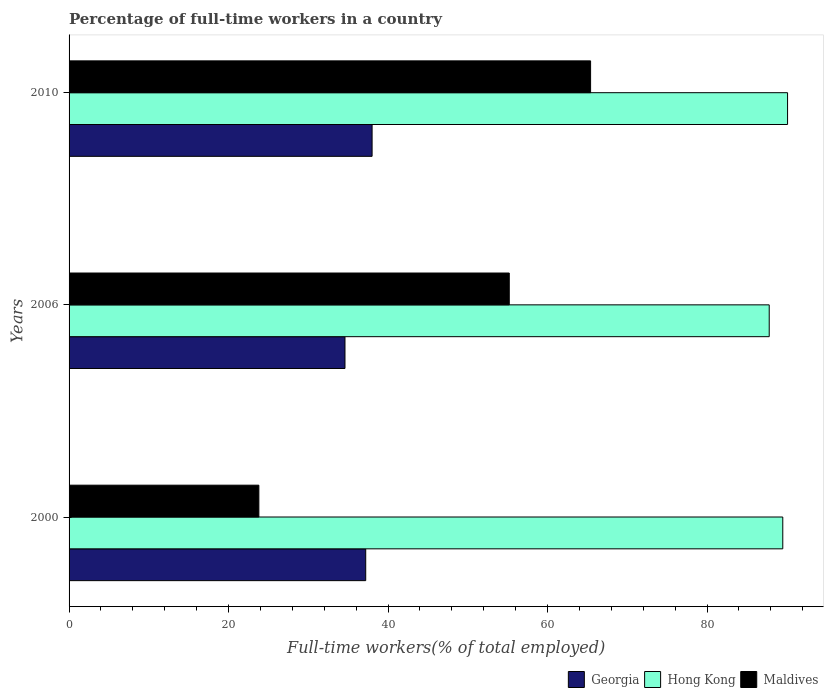How many groups of bars are there?
Provide a succinct answer. 3. Are the number of bars per tick equal to the number of legend labels?
Offer a terse response. Yes. Are the number of bars on each tick of the Y-axis equal?
Your answer should be very brief. Yes. What is the label of the 3rd group of bars from the top?
Make the answer very short. 2000. What is the percentage of full-time workers in Hong Kong in 2006?
Offer a terse response. 87.8. Across all years, what is the minimum percentage of full-time workers in Hong Kong?
Your response must be concise. 87.8. What is the total percentage of full-time workers in Hong Kong in the graph?
Provide a succinct answer. 267.4. What is the difference between the percentage of full-time workers in Georgia in 2000 and that in 2006?
Keep it short and to the point. 2.6. What is the difference between the percentage of full-time workers in Georgia in 2006 and the percentage of full-time workers in Hong Kong in 2000?
Offer a terse response. -54.9. What is the average percentage of full-time workers in Maldives per year?
Give a very brief answer. 48.13. In the year 2010, what is the difference between the percentage of full-time workers in Georgia and percentage of full-time workers in Maldives?
Your response must be concise. -27.4. In how many years, is the percentage of full-time workers in Georgia greater than 8 %?
Make the answer very short. 3. What is the ratio of the percentage of full-time workers in Hong Kong in 2000 to that in 2006?
Your answer should be compact. 1.02. Is the difference between the percentage of full-time workers in Georgia in 2006 and 2010 greater than the difference between the percentage of full-time workers in Maldives in 2006 and 2010?
Offer a terse response. Yes. What is the difference between the highest and the second highest percentage of full-time workers in Maldives?
Provide a succinct answer. 10.2. What is the difference between the highest and the lowest percentage of full-time workers in Hong Kong?
Keep it short and to the point. 2.3. In how many years, is the percentage of full-time workers in Hong Kong greater than the average percentage of full-time workers in Hong Kong taken over all years?
Provide a succinct answer. 2. Is the sum of the percentage of full-time workers in Maldives in 2006 and 2010 greater than the maximum percentage of full-time workers in Georgia across all years?
Make the answer very short. Yes. What does the 3rd bar from the top in 2006 represents?
Ensure brevity in your answer.  Georgia. What does the 1st bar from the bottom in 2006 represents?
Your answer should be compact. Georgia. How many bars are there?
Give a very brief answer. 9. Are all the bars in the graph horizontal?
Your answer should be compact. Yes. How many legend labels are there?
Give a very brief answer. 3. What is the title of the graph?
Your answer should be compact. Percentage of full-time workers in a country. Does "Luxembourg" appear as one of the legend labels in the graph?
Your response must be concise. No. What is the label or title of the X-axis?
Your answer should be compact. Full-time workers(% of total employed). What is the Full-time workers(% of total employed) of Georgia in 2000?
Offer a very short reply. 37.2. What is the Full-time workers(% of total employed) in Hong Kong in 2000?
Your answer should be compact. 89.5. What is the Full-time workers(% of total employed) of Maldives in 2000?
Offer a terse response. 23.8. What is the Full-time workers(% of total employed) in Georgia in 2006?
Offer a very short reply. 34.6. What is the Full-time workers(% of total employed) in Hong Kong in 2006?
Your answer should be very brief. 87.8. What is the Full-time workers(% of total employed) of Maldives in 2006?
Keep it short and to the point. 55.2. What is the Full-time workers(% of total employed) of Hong Kong in 2010?
Provide a succinct answer. 90.1. What is the Full-time workers(% of total employed) of Maldives in 2010?
Offer a very short reply. 65.4. Across all years, what is the maximum Full-time workers(% of total employed) in Hong Kong?
Your answer should be very brief. 90.1. Across all years, what is the maximum Full-time workers(% of total employed) in Maldives?
Keep it short and to the point. 65.4. Across all years, what is the minimum Full-time workers(% of total employed) in Georgia?
Provide a succinct answer. 34.6. Across all years, what is the minimum Full-time workers(% of total employed) of Hong Kong?
Provide a short and direct response. 87.8. Across all years, what is the minimum Full-time workers(% of total employed) in Maldives?
Give a very brief answer. 23.8. What is the total Full-time workers(% of total employed) in Georgia in the graph?
Your response must be concise. 109.8. What is the total Full-time workers(% of total employed) of Hong Kong in the graph?
Provide a short and direct response. 267.4. What is the total Full-time workers(% of total employed) of Maldives in the graph?
Offer a very short reply. 144.4. What is the difference between the Full-time workers(% of total employed) of Hong Kong in 2000 and that in 2006?
Offer a very short reply. 1.7. What is the difference between the Full-time workers(% of total employed) in Maldives in 2000 and that in 2006?
Your response must be concise. -31.4. What is the difference between the Full-time workers(% of total employed) of Georgia in 2000 and that in 2010?
Make the answer very short. -0.8. What is the difference between the Full-time workers(% of total employed) of Hong Kong in 2000 and that in 2010?
Keep it short and to the point. -0.6. What is the difference between the Full-time workers(% of total employed) of Maldives in 2000 and that in 2010?
Your answer should be compact. -41.6. What is the difference between the Full-time workers(% of total employed) of Georgia in 2000 and the Full-time workers(% of total employed) of Hong Kong in 2006?
Keep it short and to the point. -50.6. What is the difference between the Full-time workers(% of total employed) of Georgia in 2000 and the Full-time workers(% of total employed) of Maldives in 2006?
Your response must be concise. -18. What is the difference between the Full-time workers(% of total employed) of Hong Kong in 2000 and the Full-time workers(% of total employed) of Maldives in 2006?
Your response must be concise. 34.3. What is the difference between the Full-time workers(% of total employed) in Georgia in 2000 and the Full-time workers(% of total employed) in Hong Kong in 2010?
Offer a terse response. -52.9. What is the difference between the Full-time workers(% of total employed) of Georgia in 2000 and the Full-time workers(% of total employed) of Maldives in 2010?
Provide a short and direct response. -28.2. What is the difference between the Full-time workers(% of total employed) of Hong Kong in 2000 and the Full-time workers(% of total employed) of Maldives in 2010?
Ensure brevity in your answer.  24.1. What is the difference between the Full-time workers(% of total employed) of Georgia in 2006 and the Full-time workers(% of total employed) of Hong Kong in 2010?
Offer a terse response. -55.5. What is the difference between the Full-time workers(% of total employed) in Georgia in 2006 and the Full-time workers(% of total employed) in Maldives in 2010?
Offer a very short reply. -30.8. What is the difference between the Full-time workers(% of total employed) in Hong Kong in 2006 and the Full-time workers(% of total employed) in Maldives in 2010?
Make the answer very short. 22.4. What is the average Full-time workers(% of total employed) in Georgia per year?
Keep it short and to the point. 36.6. What is the average Full-time workers(% of total employed) of Hong Kong per year?
Your answer should be compact. 89.13. What is the average Full-time workers(% of total employed) of Maldives per year?
Your answer should be compact. 48.13. In the year 2000, what is the difference between the Full-time workers(% of total employed) of Georgia and Full-time workers(% of total employed) of Hong Kong?
Your answer should be compact. -52.3. In the year 2000, what is the difference between the Full-time workers(% of total employed) in Georgia and Full-time workers(% of total employed) in Maldives?
Your answer should be compact. 13.4. In the year 2000, what is the difference between the Full-time workers(% of total employed) of Hong Kong and Full-time workers(% of total employed) of Maldives?
Offer a very short reply. 65.7. In the year 2006, what is the difference between the Full-time workers(% of total employed) in Georgia and Full-time workers(% of total employed) in Hong Kong?
Your answer should be very brief. -53.2. In the year 2006, what is the difference between the Full-time workers(% of total employed) of Georgia and Full-time workers(% of total employed) of Maldives?
Keep it short and to the point. -20.6. In the year 2006, what is the difference between the Full-time workers(% of total employed) in Hong Kong and Full-time workers(% of total employed) in Maldives?
Keep it short and to the point. 32.6. In the year 2010, what is the difference between the Full-time workers(% of total employed) of Georgia and Full-time workers(% of total employed) of Hong Kong?
Give a very brief answer. -52.1. In the year 2010, what is the difference between the Full-time workers(% of total employed) of Georgia and Full-time workers(% of total employed) of Maldives?
Offer a terse response. -27.4. In the year 2010, what is the difference between the Full-time workers(% of total employed) of Hong Kong and Full-time workers(% of total employed) of Maldives?
Your answer should be very brief. 24.7. What is the ratio of the Full-time workers(% of total employed) in Georgia in 2000 to that in 2006?
Give a very brief answer. 1.08. What is the ratio of the Full-time workers(% of total employed) of Hong Kong in 2000 to that in 2006?
Provide a short and direct response. 1.02. What is the ratio of the Full-time workers(% of total employed) in Maldives in 2000 to that in 2006?
Your answer should be very brief. 0.43. What is the ratio of the Full-time workers(% of total employed) in Georgia in 2000 to that in 2010?
Give a very brief answer. 0.98. What is the ratio of the Full-time workers(% of total employed) in Hong Kong in 2000 to that in 2010?
Offer a terse response. 0.99. What is the ratio of the Full-time workers(% of total employed) in Maldives in 2000 to that in 2010?
Ensure brevity in your answer.  0.36. What is the ratio of the Full-time workers(% of total employed) in Georgia in 2006 to that in 2010?
Your answer should be very brief. 0.91. What is the ratio of the Full-time workers(% of total employed) in Hong Kong in 2006 to that in 2010?
Give a very brief answer. 0.97. What is the ratio of the Full-time workers(% of total employed) of Maldives in 2006 to that in 2010?
Your answer should be very brief. 0.84. What is the difference between the highest and the lowest Full-time workers(% of total employed) of Georgia?
Offer a terse response. 3.4. What is the difference between the highest and the lowest Full-time workers(% of total employed) of Maldives?
Make the answer very short. 41.6. 